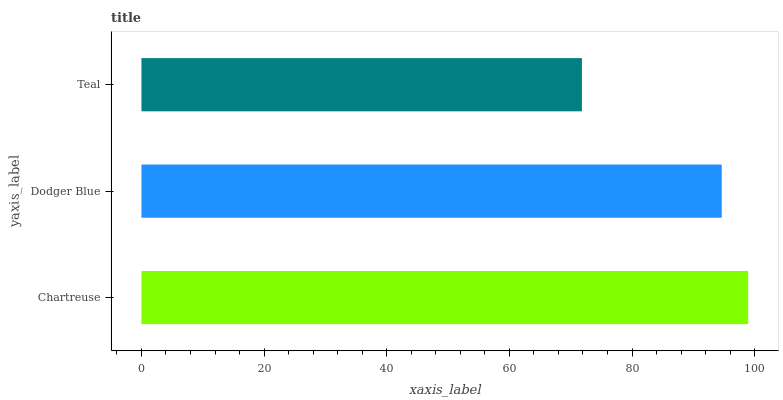Is Teal the minimum?
Answer yes or no. Yes. Is Chartreuse the maximum?
Answer yes or no. Yes. Is Dodger Blue the minimum?
Answer yes or no. No. Is Dodger Blue the maximum?
Answer yes or no. No. Is Chartreuse greater than Dodger Blue?
Answer yes or no. Yes. Is Dodger Blue less than Chartreuse?
Answer yes or no. Yes. Is Dodger Blue greater than Chartreuse?
Answer yes or no. No. Is Chartreuse less than Dodger Blue?
Answer yes or no. No. Is Dodger Blue the high median?
Answer yes or no. Yes. Is Dodger Blue the low median?
Answer yes or no. Yes. Is Chartreuse the high median?
Answer yes or no. No. Is Chartreuse the low median?
Answer yes or no. No. 